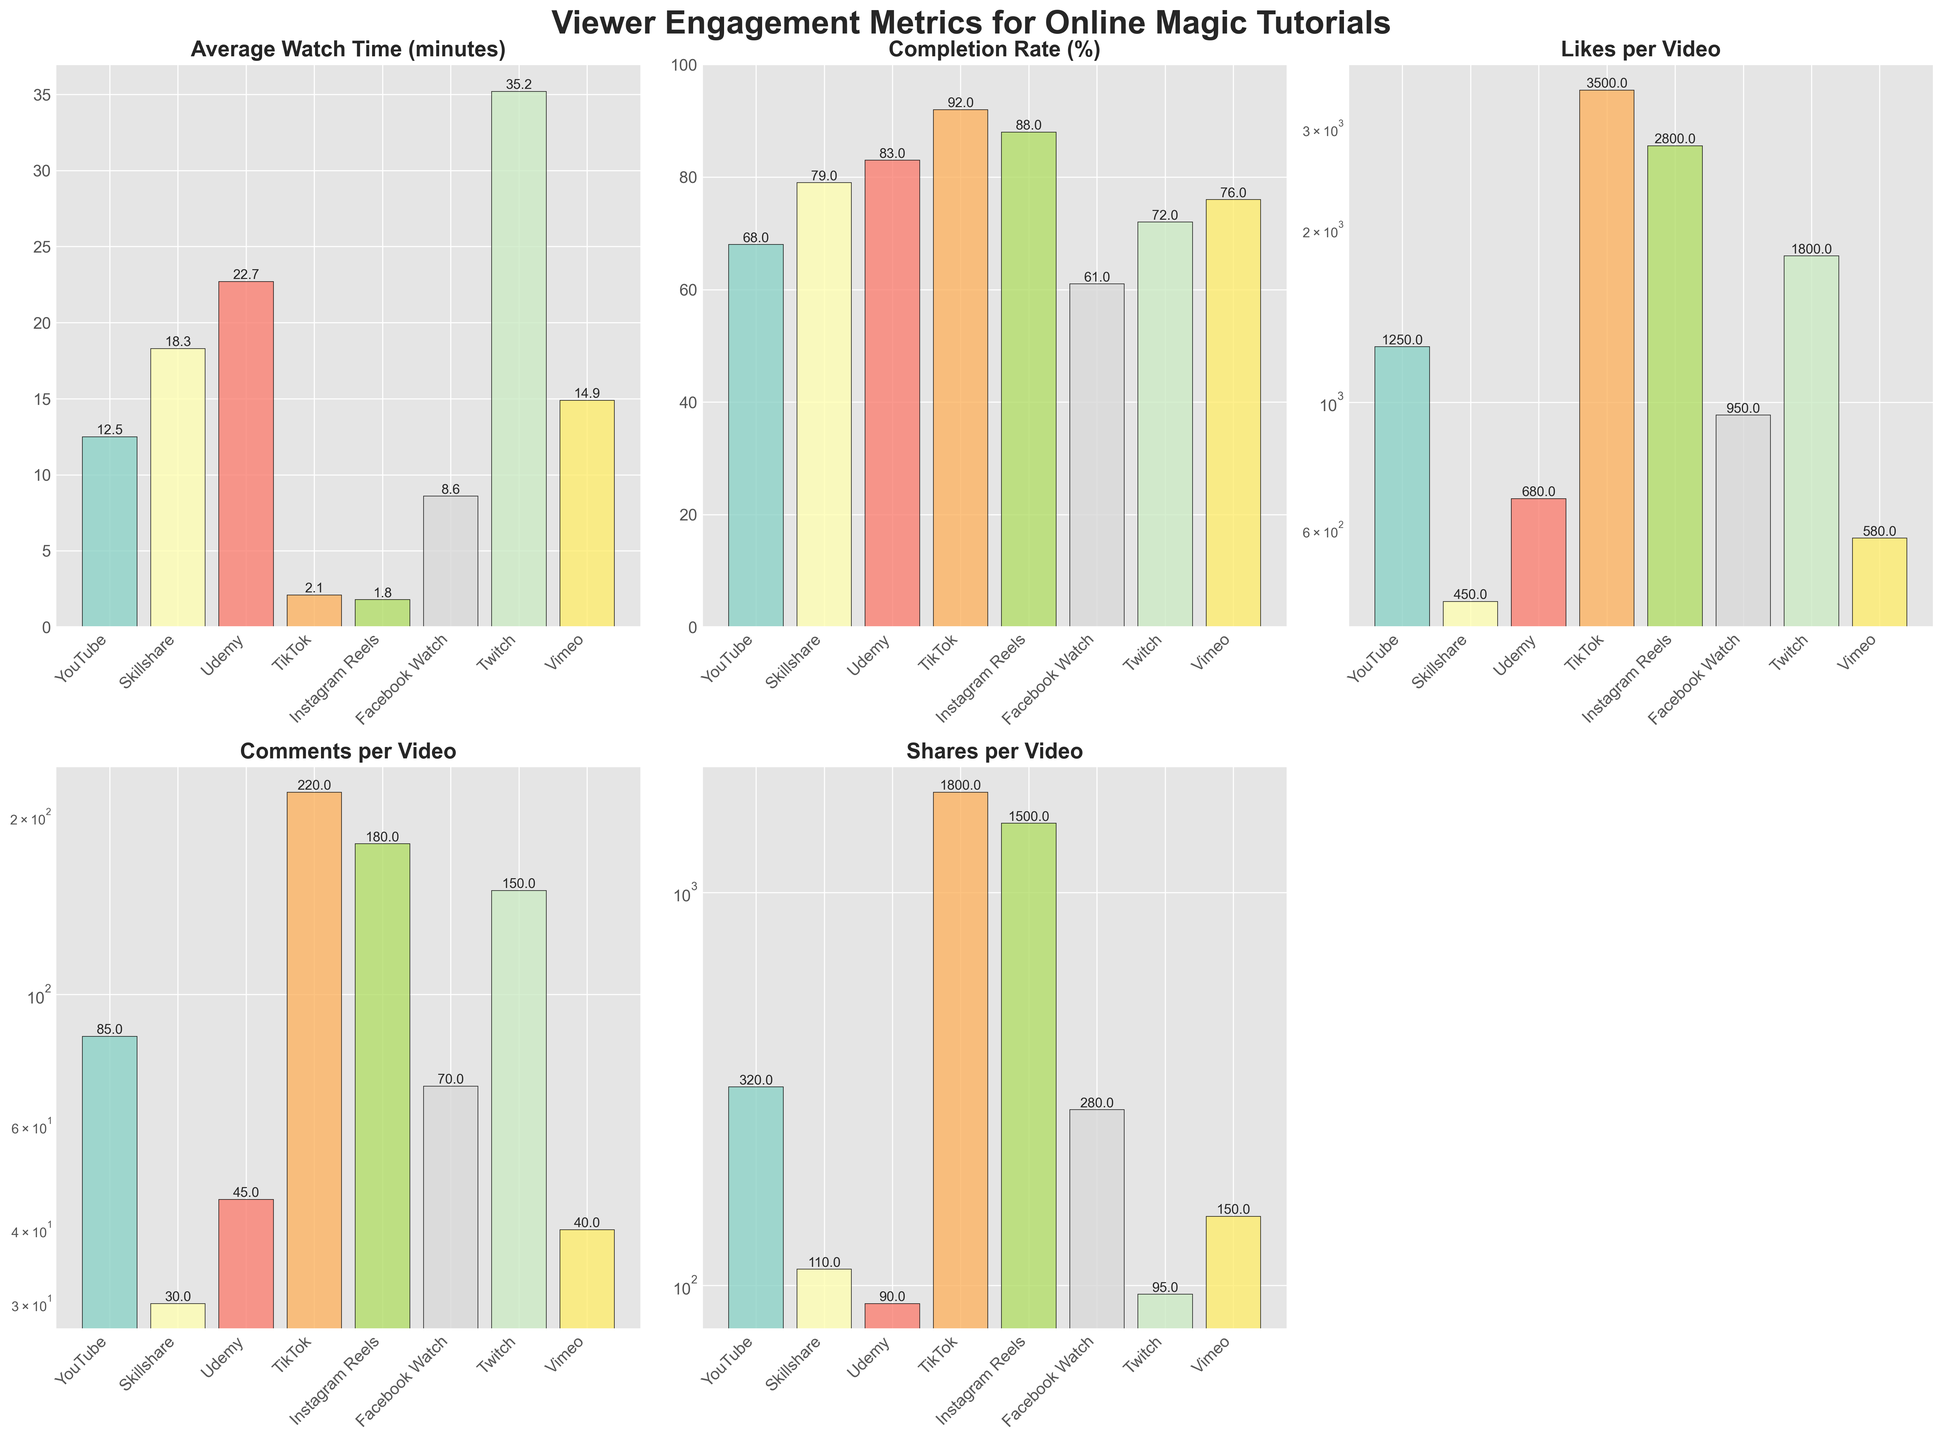What's the platform with the highest average watch time? Look at the bar for 'Average Watch Time (minutes)' and identify the tallest bar. The tallest bar is for Twitch with a value of 35.2 minutes.
Answer: Twitch Comparing YouTube and Udemy, which has a higher completion rate? Look at the 'Completion Rate (%)' bars for both YouTube and Udemy. Udemy's bar is higher at 83% compared to YouTube's 68%.
Answer: Udemy What is the combined total of comments per video across YouTube and TikTok? Look at the 'Comments per Video' bars for YouTube and TikTok. YouTube has 85 and TikTok has 220 comments per video. Adding these together, 85 + 220 = 305.
Answer: 305 Which platform has the lowest average watch time and what is the value? Identify the shortest bar in the 'Average Watch Time (minutes)' chart. Instagram Reels has the shortest bar with a value of 1.8 minutes.
Answer: Instagram Reels, 1.8 How does the completion rate for Instagram Reels compare to Facebook Watch? Look at the 'Completion Rate (%)' bars for Instagram Reels and Facebook Watch. Instagram Reels has a higher completion rate at 88% compared to Facebook Watch's 61%.
Answer: Instagram Reels has a higher completion rate What's the average number of shares per video among all platforms? Sum the 'Shares per Video' values for all platforms and divide by the number of platforms. (320 + 110 + 90 + 1800 + 1500 + 280 + 95 + 150) / 8 = 4345 / 8 = 543.125
Answer: 543.125 Which platform has the most shares per video and what is the value? Look at the 'Shares per Video' bars and find the tallest one. TikTok has the tallest bar with a value of 1800 shares per video.
Answer: TikTok, 1800 What's the second-highest platform in terms of likes per video? Look at the 'Likes per Video' bars, identify the highest and the second highest bars. TikTok is the highest with 3500 likes, followed by Instagram Reels with 2800 likes.
Answer: Instagram Reels What is the relation in average watch time between Vimeo and Facebook Watch? Compare the heights of the 'Average Watch Time (minutes)' bars for Vimeo and Facebook Watch. Vimeo's average watch time is higher at 14.9 minutes compared to Facebook Watch's 8.6 minutes.
Answer: Vimeo is higher if the average watch time on Udemy was double, what would the new value be? The current average watch time on Udemy is 22.7 minutes. Doubling this value, 22.7 * 2 = 45.4.
Answer: 45.4 